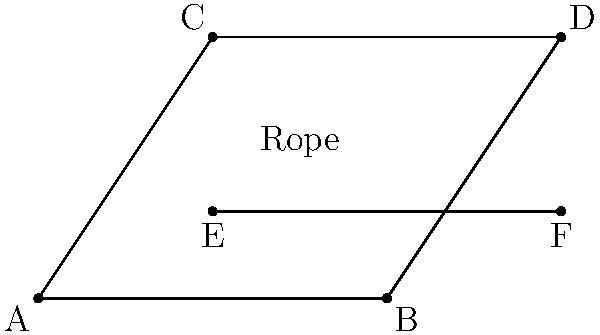In the diagram of a rope trick setup, ABCD represents a rectangular frame, and EF represents a rope stretched across the frame. If AE = BF and CE = DF, what can you conclude about segments AC and BD? Let's approach this step-by-step:

1) First, we need to recall that if two triangles have all three sides congruent, they are congruent by the Side-Side-Side (SSS) congruence criterion.

2) In this diagram, we're given that AE = BF and CE = DF.

3) We also know that EF is common to both triangles AEF and BEF.

4) Therefore, triangles AEF and BEF have all three sides congruent:
   - AE = BF (given)
   - EF is common
   - AF = BE (opposite sides of a rectangle are equal)

5) By the SSS congruence criterion, triangle AEF ≅ triangle BEF.

6) In congruent triangles, corresponding angles are equal. So, ∠FAE = ∠FBE.

7) Similarly, we can prove that triangle CEF ≅ triangle DEF, and ∠FCE = ∠FDE.

8) Now, in triangle ACE:
   - ∠CAE = 90° - ∠FAE (complementary angles in a right triangle)
   - ∠ACE = 90° - ∠FCE (complementary angles in a right triangle)

9) And in triangle BDE:
   - ∠DBE = 90° - ∠FBE = 90° - ∠FAE (from step 6)
   - ∠BDE = 90° - ∠FDE = 90° - ∠FCE (from step 7)

10) Therefore, triangle ACE ≅ triangle BDE (by the Angle-Angle-Side congruence criterion).

11) In congruent triangles, corresponding sides are equal. So, AC = BD.

Thus, we can conclude that segments AC and BD are congruent.
Answer: AC ≅ BD 